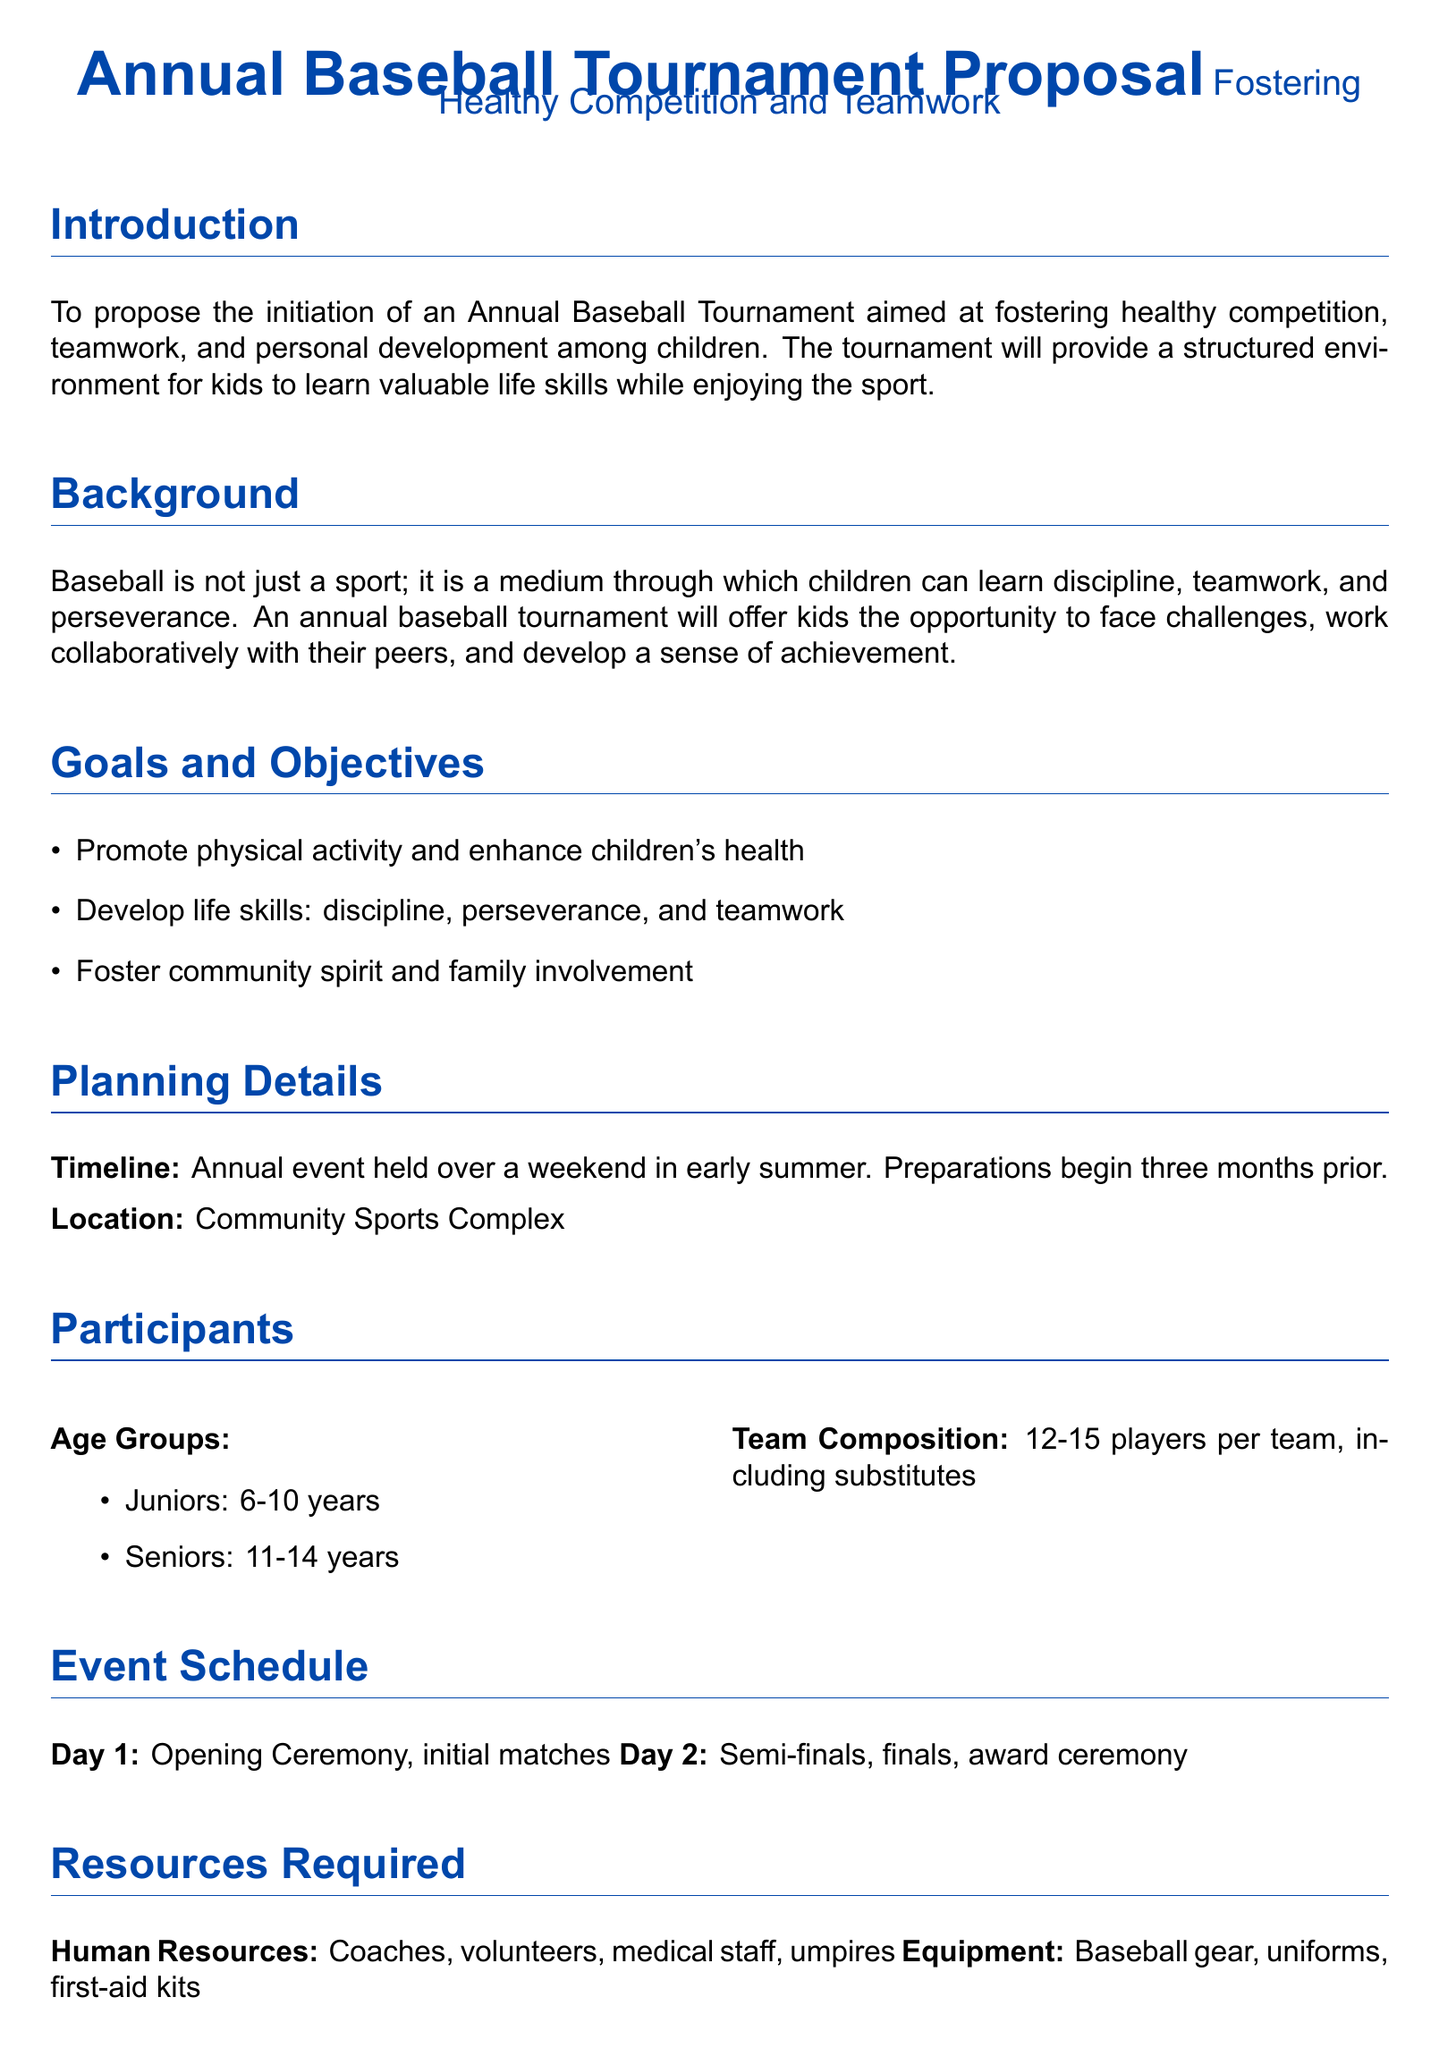What is the objective of the tournament? The objective of the tournament is to foster healthy competition, teamwork, and personal development among children.
Answer: Fostering healthy competition, teamwork, and personal development What age groups are participating? The document specifies the age groups for participants, which are Juniors and Seniors.
Answer: Juniors: 6-10 years, Seniors: 11-14 years What is the venue for the tournament? The proposal mentions the location for the event as part of the planning details.
Answer: Community Sports Complex How many players are there per team? The document outlines the composition of teams including substitutes.
Answer: 12-15 players per team What is the timeline for the tournament? The planning section states the schedule for preparations and the timing of the event.
Answer: Annual event held over a weekend in early summer What is included in the budget estimate? The document outlines how the budget will be managed, mentioning specific sources of funding.
Answer: Nominal registration fees, local business sponsorships What benefits does the tournament provide to the community? The proposal lists the community benefits that result from the tournament.
Answer: Improved physical fitness, mental resilience, and social skills for children What type of event is scheduled for Day 1? The event schedule gives a brief overview of activities planned for the first day of the tournament.
Answer: Opening Ceremony, initial matches What is a key life skill that children will develop through the tournament? The goals and objectives section emphasizes specific skills that the tournament aims to nurture.
Answer: Discipline, perseverance, teamwork 